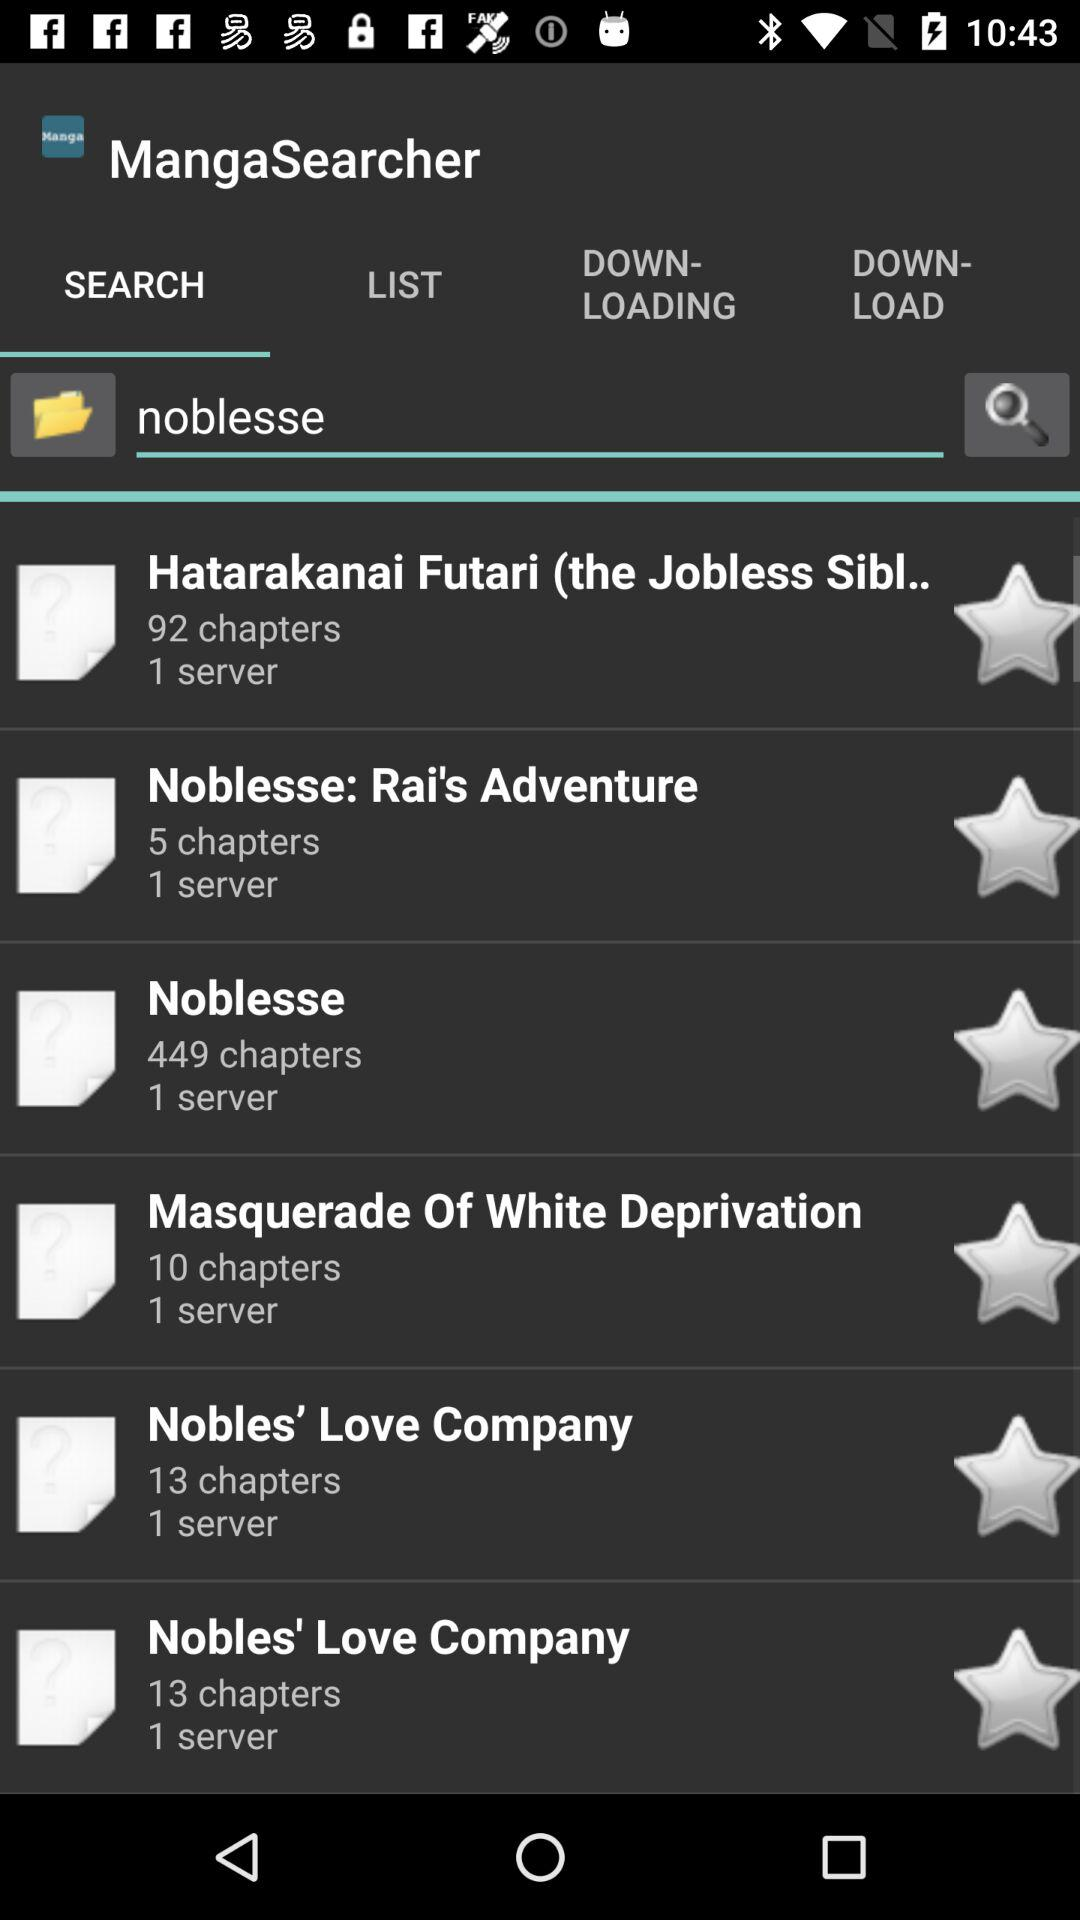How many chapters are there in "Noblesse"? There are 449 chapters in "Noblesse". 